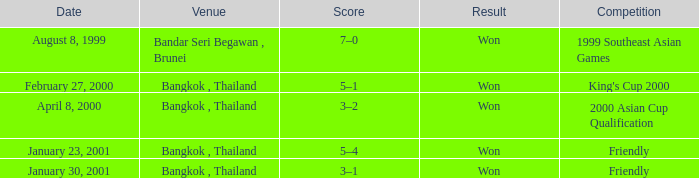What was the outcome of the match held on february 27, 2000? Won. Could you help me parse every detail presented in this table? {'header': ['Date', 'Venue', 'Score', 'Result', 'Competition'], 'rows': [['August 8, 1999', 'Bandar Seri Begawan , Brunei', '7–0', 'Won', '1999 Southeast Asian Games'], ['February 27, 2000', 'Bangkok , Thailand', '5–1', 'Won', "King's Cup 2000"], ['April 8, 2000', 'Bangkok , Thailand', '3–2', 'Won', '2000 Asian Cup Qualification'], ['January 23, 2001', 'Bangkok , Thailand', '5–4', 'Won', 'Friendly'], ['January 30, 2001', 'Bangkok , Thailand', '3–1', 'Won', 'Friendly']]} 